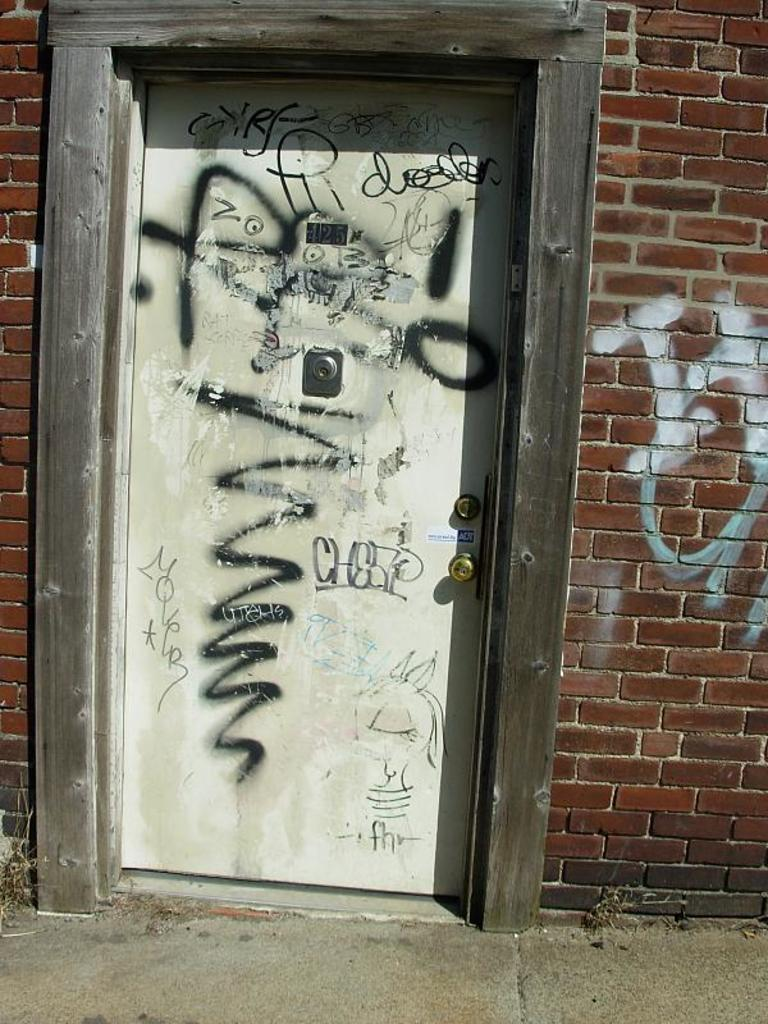What is the main subject of the image? The main subject of the image is a building. Can you describe any text visible on the building? Yes, there is text on the door and the wall of the building. What is located at the bottom of the image? There is a road at the bottom of the image. What type of poison is being stored in the building in the image? There is no indication of poison or any storage of hazardous materials in the image; it simply depicts a building with text on the door and wall. 